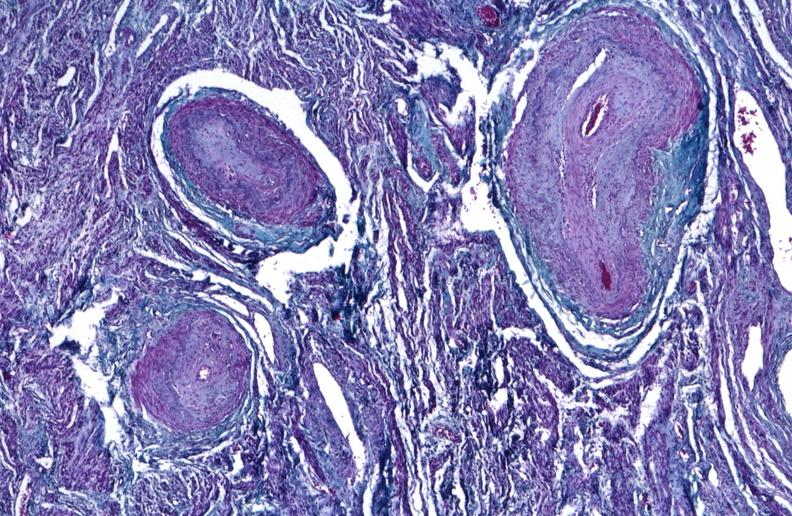do trichrome stain?
Answer the question using a single word or phrase. Yes 